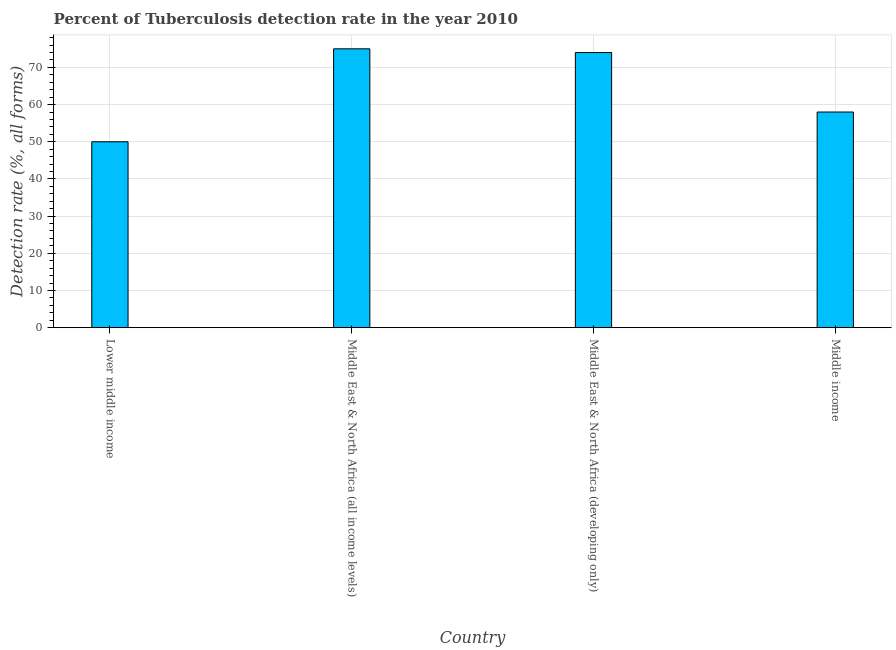Does the graph contain any zero values?
Your response must be concise. No. Does the graph contain grids?
Make the answer very short. Yes. What is the title of the graph?
Your response must be concise. Percent of Tuberculosis detection rate in the year 2010. What is the label or title of the X-axis?
Your answer should be compact. Country. What is the label or title of the Y-axis?
Offer a terse response. Detection rate (%, all forms). Across all countries, what is the maximum detection rate of tuberculosis?
Your response must be concise. 75. Across all countries, what is the minimum detection rate of tuberculosis?
Your answer should be compact. 50. In which country was the detection rate of tuberculosis maximum?
Your answer should be compact. Middle East & North Africa (all income levels). In which country was the detection rate of tuberculosis minimum?
Ensure brevity in your answer.  Lower middle income. What is the sum of the detection rate of tuberculosis?
Your answer should be compact. 257. What is the difference between the detection rate of tuberculosis in Middle East & North Africa (all income levels) and Middle East & North Africa (developing only)?
Your answer should be very brief. 1. What is the average detection rate of tuberculosis per country?
Offer a terse response. 64. What is the median detection rate of tuberculosis?
Your answer should be very brief. 66. In how many countries, is the detection rate of tuberculosis greater than 30 %?
Offer a very short reply. 4. What is the ratio of the detection rate of tuberculosis in Middle East & North Africa (all income levels) to that in Middle income?
Make the answer very short. 1.29. Is the detection rate of tuberculosis in Middle East & North Africa (all income levels) less than that in Middle income?
Offer a terse response. No. Is the difference between the detection rate of tuberculosis in Lower middle income and Middle East & North Africa (developing only) greater than the difference between any two countries?
Offer a very short reply. No. Is the sum of the detection rate of tuberculosis in Lower middle income and Middle East & North Africa (all income levels) greater than the maximum detection rate of tuberculosis across all countries?
Provide a short and direct response. Yes. In how many countries, is the detection rate of tuberculosis greater than the average detection rate of tuberculosis taken over all countries?
Offer a very short reply. 2. What is the difference between two consecutive major ticks on the Y-axis?
Your answer should be very brief. 10. Are the values on the major ticks of Y-axis written in scientific E-notation?
Give a very brief answer. No. What is the Detection rate (%, all forms) of Middle East & North Africa (all income levels)?
Offer a very short reply. 75. What is the Detection rate (%, all forms) in Middle East & North Africa (developing only)?
Make the answer very short. 74. What is the difference between the Detection rate (%, all forms) in Middle East & North Africa (all income levels) and Middle income?
Make the answer very short. 17. What is the ratio of the Detection rate (%, all forms) in Lower middle income to that in Middle East & North Africa (all income levels)?
Provide a succinct answer. 0.67. What is the ratio of the Detection rate (%, all forms) in Lower middle income to that in Middle East & North Africa (developing only)?
Your answer should be compact. 0.68. What is the ratio of the Detection rate (%, all forms) in Lower middle income to that in Middle income?
Offer a terse response. 0.86. What is the ratio of the Detection rate (%, all forms) in Middle East & North Africa (all income levels) to that in Middle East & North Africa (developing only)?
Offer a very short reply. 1.01. What is the ratio of the Detection rate (%, all forms) in Middle East & North Africa (all income levels) to that in Middle income?
Give a very brief answer. 1.29. What is the ratio of the Detection rate (%, all forms) in Middle East & North Africa (developing only) to that in Middle income?
Your response must be concise. 1.28. 